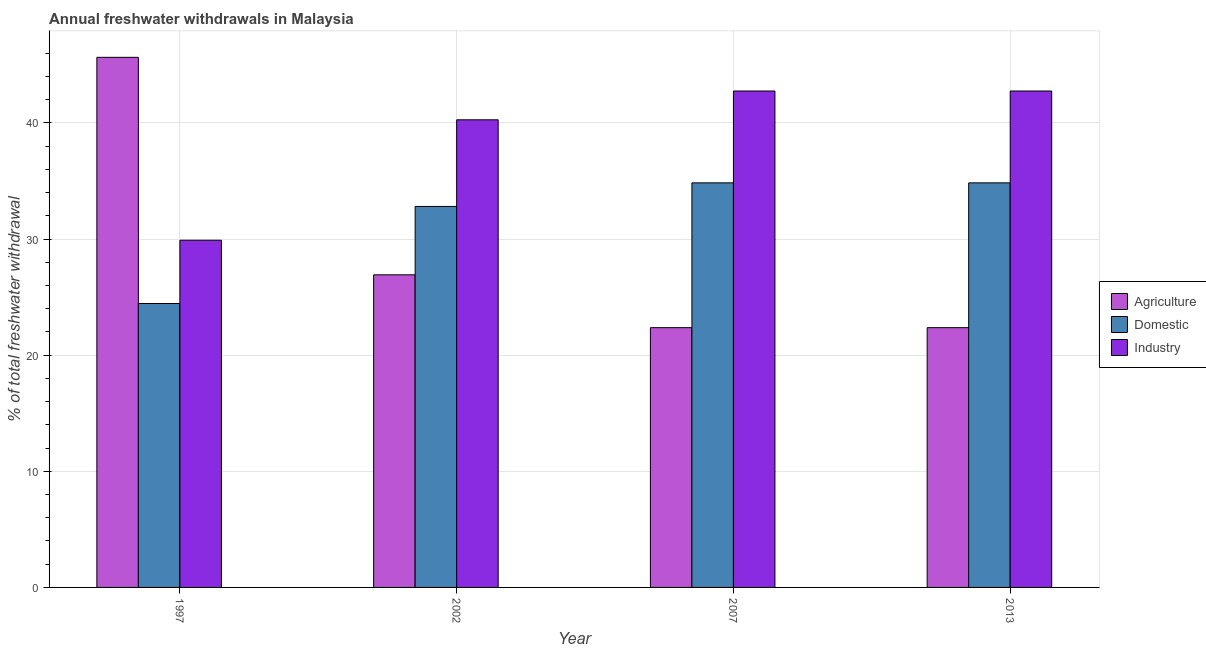What is the percentage of freshwater withdrawal for domestic purposes in 2007?
Give a very brief answer. 34.84. Across all years, what is the maximum percentage of freshwater withdrawal for industry?
Give a very brief answer. 42.75. Across all years, what is the minimum percentage of freshwater withdrawal for industry?
Provide a succinct answer. 29.9. In which year was the percentage of freshwater withdrawal for agriculture maximum?
Offer a very short reply. 1997. What is the total percentage of freshwater withdrawal for industry in the graph?
Ensure brevity in your answer.  155.67. What is the difference between the percentage of freshwater withdrawal for industry in 2002 and that in 2007?
Make the answer very short. -2.48. What is the difference between the percentage of freshwater withdrawal for domestic purposes in 2007 and the percentage of freshwater withdrawal for agriculture in 2002?
Offer a terse response. 2.03. What is the average percentage of freshwater withdrawal for domestic purposes per year?
Your answer should be compact. 31.74. In the year 2002, what is the difference between the percentage of freshwater withdrawal for industry and percentage of freshwater withdrawal for agriculture?
Offer a very short reply. 0. What is the difference between the highest and the lowest percentage of freshwater withdrawal for agriculture?
Offer a very short reply. 23.28. What does the 2nd bar from the left in 2013 represents?
Offer a terse response. Domestic. What does the 2nd bar from the right in 2007 represents?
Make the answer very short. Domestic. How many years are there in the graph?
Provide a short and direct response. 4. What is the difference between two consecutive major ticks on the Y-axis?
Provide a short and direct response. 10. Does the graph contain grids?
Provide a succinct answer. Yes. Where does the legend appear in the graph?
Your response must be concise. Center right. How many legend labels are there?
Ensure brevity in your answer.  3. What is the title of the graph?
Your answer should be very brief. Annual freshwater withdrawals in Malaysia. What is the label or title of the X-axis?
Provide a short and direct response. Year. What is the label or title of the Y-axis?
Ensure brevity in your answer.  % of total freshwater withdrawal. What is the % of total freshwater withdrawal of Agriculture in 1997?
Make the answer very short. 45.65. What is the % of total freshwater withdrawal in Domestic in 1997?
Give a very brief answer. 24.45. What is the % of total freshwater withdrawal of Industry in 1997?
Your answer should be compact. 29.9. What is the % of total freshwater withdrawal in Agriculture in 2002?
Ensure brevity in your answer.  26.92. What is the % of total freshwater withdrawal of Domestic in 2002?
Offer a very short reply. 32.81. What is the % of total freshwater withdrawal of Industry in 2002?
Your answer should be very brief. 40.27. What is the % of total freshwater withdrawal of Agriculture in 2007?
Your answer should be very brief. 22.37. What is the % of total freshwater withdrawal of Domestic in 2007?
Provide a succinct answer. 34.84. What is the % of total freshwater withdrawal of Industry in 2007?
Make the answer very short. 42.75. What is the % of total freshwater withdrawal of Agriculture in 2013?
Your response must be concise. 22.37. What is the % of total freshwater withdrawal of Domestic in 2013?
Ensure brevity in your answer.  34.84. What is the % of total freshwater withdrawal in Industry in 2013?
Keep it short and to the point. 42.75. Across all years, what is the maximum % of total freshwater withdrawal of Agriculture?
Offer a terse response. 45.65. Across all years, what is the maximum % of total freshwater withdrawal of Domestic?
Keep it short and to the point. 34.84. Across all years, what is the maximum % of total freshwater withdrawal of Industry?
Provide a short and direct response. 42.75. Across all years, what is the minimum % of total freshwater withdrawal of Agriculture?
Offer a terse response. 22.37. Across all years, what is the minimum % of total freshwater withdrawal of Domestic?
Provide a succinct answer. 24.45. Across all years, what is the minimum % of total freshwater withdrawal in Industry?
Provide a succinct answer. 29.9. What is the total % of total freshwater withdrawal of Agriculture in the graph?
Offer a very short reply. 117.31. What is the total % of total freshwater withdrawal in Domestic in the graph?
Give a very brief answer. 126.94. What is the total % of total freshwater withdrawal of Industry in the graph?
Offer a terse response. 155.67. What is the difference between the % of total freshwater withdrawal in Agriculture in 1997 and that in 2002?
Your answer should be compact. 18.73. What is the difference between the % of total freshwater withdrawal of Domestic in 1997 and that in 2002?
Make the answer very short. -8.36. What is the difference between the % of total freshwater withdrawal of Industry in 1997 and that in 2002?
Offer a terse response. -10.37. What is the difference between the % of total freshwater withdrawal of Agriculture in 1997 and that in 2007?
Your answer should be very brief. 23.28. What is the difference between the % of total freshwater withdrawal of Domestic in 1997 and that in 2007?
Provide a short and direct response. -10.39. What is the difference between the % of total freshwater withdrawal of Industry in 1997 and that in 2007?
Provide a succinct answer. -12.85. What is the difference between the % of total freshwater withdrawal in Agriculture in 1997 and that in 2013?
Your answer should be compact. 23.28. What is the difference between the % of total freshwater withdrawal of Domestic in 1997 and that in 2013?
Offer a very short reply. -10.39. What is the difference between the % of total freshwater withdrawal in Industry in 1997 and that in 2013?
Keep it short and to the point. -12.85. What is the difference between the % of total freshwater withdrawal of Agriculture in 2002 and that in 2007?
Offer a terse response. 4.55. What is the difference between the % of total freshwater withdrawal of Domestic in 2002 and that in 2007?
Your answer should be compact. -2.03. What is the difference between the % of total freshwater withdrawal of Industry in 2002 and that in 2007?
Provide a short and direct response. -2.48. What is the difference between the % of total freshwater withdrawal of Agriculture in 2002 and that in 2013?
Your response must be concise. 4.55. What is the difference between the % of total freshwater withdrawal of Domestic in 2002 and that in 2013?
Offer a very short reply. -2.03. What is the difference between the % of total freshwater withdrawal in Industry in 2002 and that in 2013?
Your answer should be compact. -2.48. What is the difference between the % of total freshwater withdrawal of Agriculture in 2007 and that in 2013?
Give a very brief answer. 0. What is the difference between the % of total freshwater withdrawal of Domestic in 2007 and that in 2013?
Your answer should be very brief. 0. What is the difference between the % of total freshwater withdrawal in Industry in 2007 and that in 2013?
Provide a succinct answer. 0. What is the difference between the % of total freshwater withdrawal of Agriculture in 1997 and the % of total freshwater withdrawal of Domestic in 2002?
Your answer should be compact. 12.84. What is the difference between the % of total freshwater withdrawal of Agriculture in 1997 and the % of total freshwater withdrawal of Industry in 2002?
Offer a very short reply. 5.38. What is the difference between the % of total freshwater withdrawal in Domestic in 1997 and the % of total freshwater withdrawal in Industry in 2002?
Offer a terse response. -15.82. What is the difference between the % of total freshwater withdrawal of Agriculture in 1997 and the % of total freshwater withdrawal of Domestic in 2007?
Your answer should be compact. 10.81. What is the difference between the % of total freshwater withdrawal of Agriculture in 1997 and the % of total freshwater withdrawal of Industry in 2007?
Your answer should be compact. 2.9. What is the difference between the % of total freshwater withdrawal of Domestic in 1997 and the % of total freshwater withdrawal of Industry in 2007?
Your answer should be compact. -18.3. What is the difference between the % of total freshwater withdrawal in Agriculture in 1997 and the % of total freshwater withdrawal in Domestic in 2013?
Offer a terse response. 10.81. What is the difference between the % of total freshwater withdrawal of Agriculture in 1997 and the % of total freshwater withdrawal of Industry in 2013?
Make the answer very short. 2.9. What is the difference between the % of total freshwater withdrawal in Domestic in 1997 and the % of total freshwater withdrawal in Industry in 2013?
Provide a succinct answer. -18.3. What is the difference between the % of total freshwater withdrawal in Agriculture in 2002 and the % of total freshwater withdrawal in Domestic in 2007?
Your answer should be very brief. -7.92. What is the difference between the % of total freshwater withdrawal in Agriculture in 2002 and the % of total freshwater withdrawal in Industry in 2007?
Offer a very short reply. -15.83. What is the difference between the % of total freshwater withdrawal of Domestic in 2002 and the % of total freshwater withdrawal of Industry in 2007?
Your answer should be compact. -9.94. What is the difference between the % of total freshwater withdrawal of Agriculture in 2002 and the % of total freshwater withdrawal of Domestic in 2013?
Offer a terse response. -7.92. What is the difference between the % of total freshwater withdrawal of Agriculture in 2002 and the % of total freshwater withdrawal of Industry in 2013?
Ensure brevity in your answer.  -15.83. What is the difference between the % of total freshwater withdrawal of Domestic in 2002 and the % of total freshwater withdrawal of Industry in 2013?
Your answer should be very brief. -9.94. What is the difference between the % of total freshwater withdrawal in Agriculture in 2007 and the % of total freshwater withdrawal in Domestic in 2013?
Give a very brief answer. -12.47. What is the difference between the % of total freshwater withdrawal in Agriculture in 2007 and the % of total freshwater withdrawal in Industry in 2013?
Give a very brief answer. -20.38. What is the difference between the % of total freshwater withdrawal in Domestic in 2007 and the % of total freshwater withdrawal in Industry in 2013?
Your response must be concise. -7.91. What is the average % of total freshwater withdrawal in Agriculture per year?
Make the answer very short. 29.33. What is the average % of total freshwater withdrawal of Domestic per year?
Offer a terse response. 31.73. What is the average % of total freshwater withdrawal of Industry per year?
Your answer should be compact. 38.92. In the year 1997, what is the difference between the % of total freshwater withdrawal in Agriculture and % of total freshwater withdrawal in Domestic?
Your answer should be very brief. 21.2. In the year 1997, what is the difference between the % of total freshwater withdrawal in Agriculture and % of total freshwater withdrawal in Industry?
Keep it short and to the point. 15.75. In the year 1997, what is the difference between the % of total freshwater withdrawal in Domestic and % of total freshwater withdrawal in Industry?
Your answer should be very brief. -5.45. In the year 2002, what is the difference between the % of total freshwater withdrawal of Agriculture and % of total freshwater withdrawal of Domestic?
Your response must be concise. -5.89. In the year 2002, what is the difference between the % of total freshwater withdrawal of Agriculture and % of total freshwater withdrawal of Industry?
Offer a very short reply. -13.35. In the year 2002, what is the difference between the % of total freshwater withdrawal of Domestic and % of total freshwater withdrawal of Industry?
Offer a very short reply. -7.46. In the year 2007, what is the difference between the % of total freshwater withdrawal of Agriculture and % of total freshwater withdrawal of Domestic?
Offer a terse response. -12.47. In the year 2007, what is the difference between the % of total freshwater withdrawal of Agriculture and % of total freshwater withdrawal of Industry?
Keep it short and to the point. -20.38. In the year 2007, what is the difference between the % of total freshwater withdrawal in Domestic and % of total freshwater withdrawal in Industry?
Ensure brevity in your answer.  -7.91. In the year 2013, what is the difference between the % of total freshwater withdrawal of Agriculture and % of total freshwater withdrawal of Domestic?
Give a very brief answer. -12.47. In the year 2013, what is the difference between the % of total freshwater withdrawal of Agriculture and % of total freshwater withdrawal of Industry?
Your answer should be compact. -20.38. In the year 2013, what is the difference between the % of total freshwater withdrawal in Domestic and % of total freshwater withdrawal in Industry?
Your response must be concise. -7.91. What is the ratio of the % of total freshwater withdrawal in Agriculture in 1997 to that in 2002?
Your answer should be very brief. 1.7. What is the ratio of the % of total freshwater withdrawal of Domestic in 1997 to that in 2002?
Your response must be concise. 0.75. What is the ratio of the % of total freshwater withdrawal of Industry in 1997 to that in 2002?
Give a very brief answer. 0.74. What is the ratio of the % of total freshwater withdrawal in Agriculture in 1997 to that in 2007?
Your answer should be compact. 2.04. What is the ratio of the % of total freshwater withdrawal in Domestic in 1997 to that in 2007?
Ensure brevity in your answer.  0.7. What is the ratio of the % of total freshwater withdrawal of Industry in 1997 to that in 2007?
Make the answer very short. 0.7. What is the ratio of the % of total freshwater withdrawal in Agriculture in 1997 to that in 2013?
Keep it short and to the point. 2.04. What is the ratio of the % of total freshwater withdrawal in Domestic in 1997 to that in 2013?
Make the answer very short. 0.7. What is the ratio of the % of total freshwater withdrawal of Industry in 1997 to that in 2013?
Offer a very short reply. 0.7. What is the ratio of the % of total freshwater withdrawal of Agriculture in 2002 to that in 2007?
Offer a terse response. 1.2. What is the ratio of the % of total freshwater withdrawal in Domestic in 2002 to that in 2007?
Offer a very short reply. 0.94. What is the ratio of the % of total freshwater withdrawal of Industry in 2002 to that in 2007?
Provide a short and direct response. 0.94. What is the ratio of the % of total freshwater withdrawal of Agriculture in 2002 to that in 2013?
Offer a terse response. 1.2. What is the ratio of the % of total freshwater withdrawal of Domestic in 2002 to that in 2013?
Offer a very short reply. 0.94. What is the ratio of the % of total freshwater withdrawal in Industry in 2002 to that in 2013?
Make the answer very short. 0.94. What is the ratio of the % of total freshwater withdrawal in Agriculture in 2007 to that in 2013?
Offer a very short reply. 1. What is the difference between the highest and the second highest % of total freshwater withdrawal of Agriculture?
Your answer should be compact. 18.73. What is the difference between the highest and the lowest % of total freshwater withdrawal in Agriculture?
Offer a very short reply. 23.28. What is the difference between the highest and the lowest % of total freshwater withdrawal of Domestic?
Your answer should be very brief. 10.39. What is the difference between the highest and the lowest % of total freshwater withdrawal of Industry?
Your answer should be very brief. 12.85. 